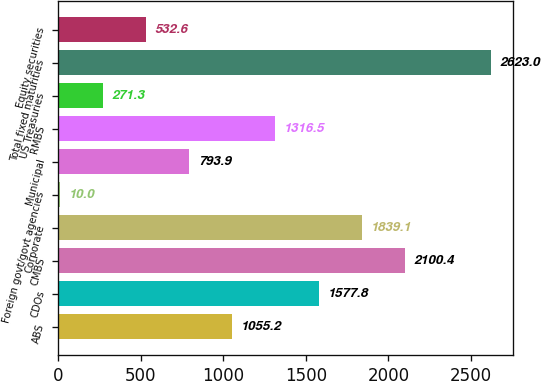Convert chart. <chart><loc_0><loc_0><loc_500><loc_500><bar_chart><fcel>ABS<fcel>CDOs<fcel>CMBS<fcel>Corporate<fcel>Foreign govt/govt agencies<fcel>Municipal<fcel>RMBS<fcel>US Treasuries<fcel>Total fixed maturities<fcel>Equity securities<nl><fcel>1055.2<fcel>1577.8<fcel>2100.4<fcel>1839.1<fcel>10<fcel>793.9<fcel>1316.5<fcel>271.3<fcel>2623<fcel>532.6<nl></chart> 